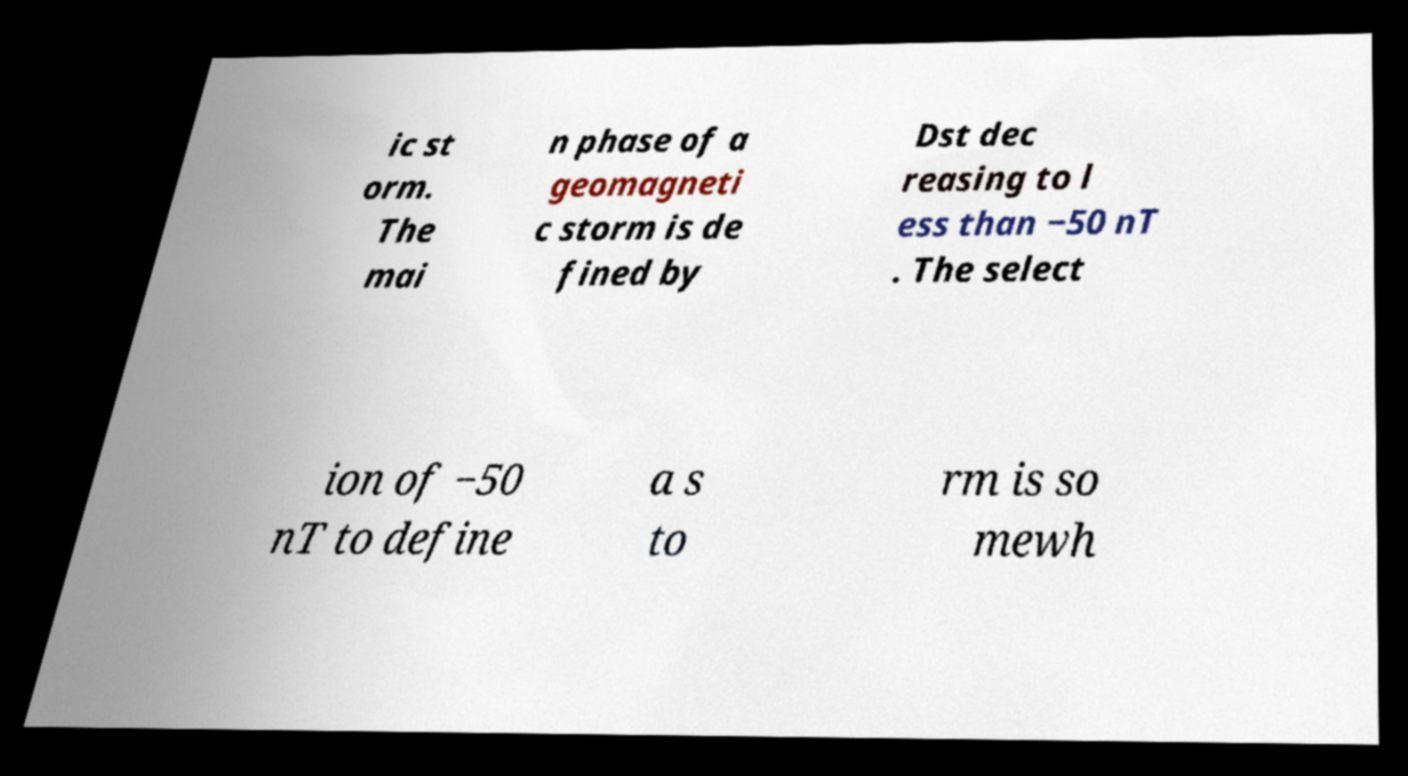Could you assist in decoding the text presented in this image and type it out clearly? ic st orm. The mai n phase of a geomagneti c storm is de fined by Dst dec reasing to l ess than −50 nT . The select ion of −50 nT to define a s to rm is so mewh 